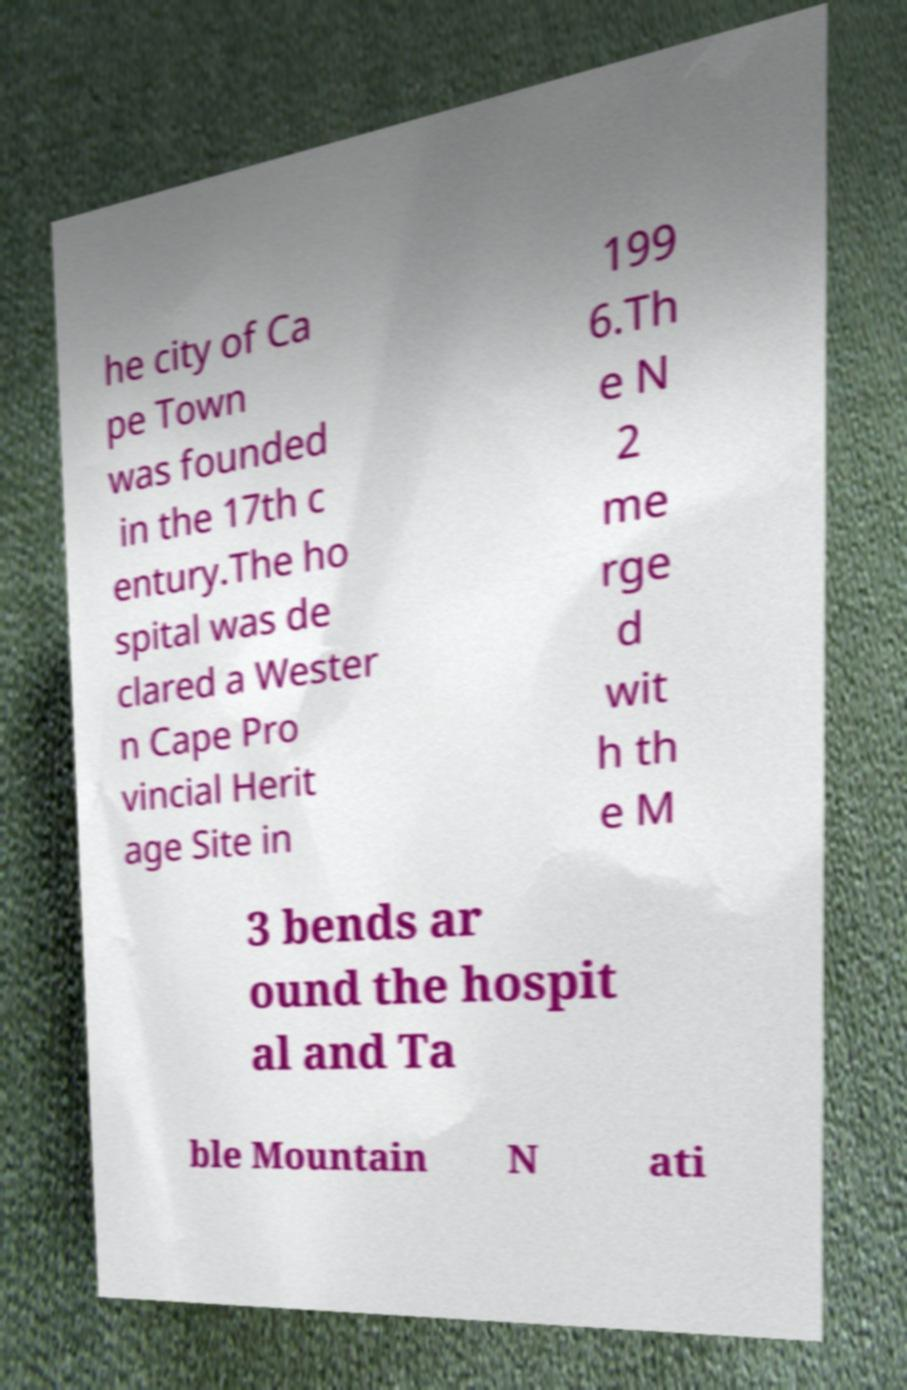Can you accurately transcribe the text from the provided image for me? he city of Ca pe Town was founded in the 17th c entury.The ho spital was de clared a Wester n Cape Pro vincial Herit age Site in 199 6.Th e N 2 me rge d wit h th e M 3 bends ar ound the hospit al and Ta ble Mountain N ati 